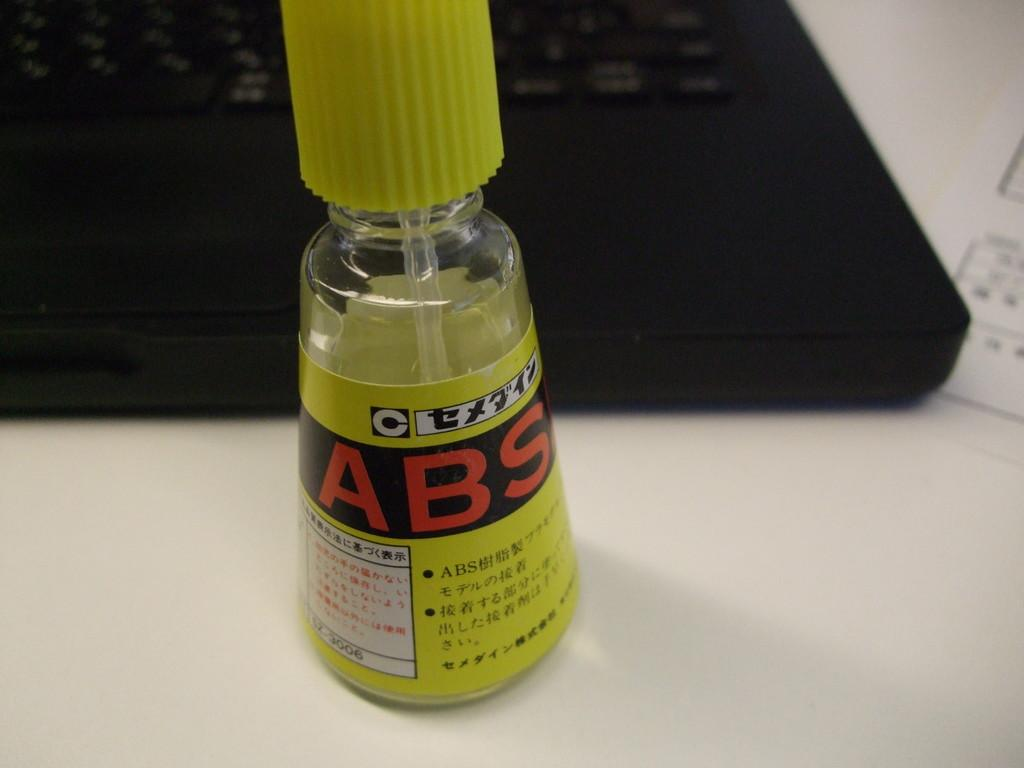<image>
Give a short and clear explanation of the subsequent image. a yellow labeled bottle with a yellow top that says "abs" on it 